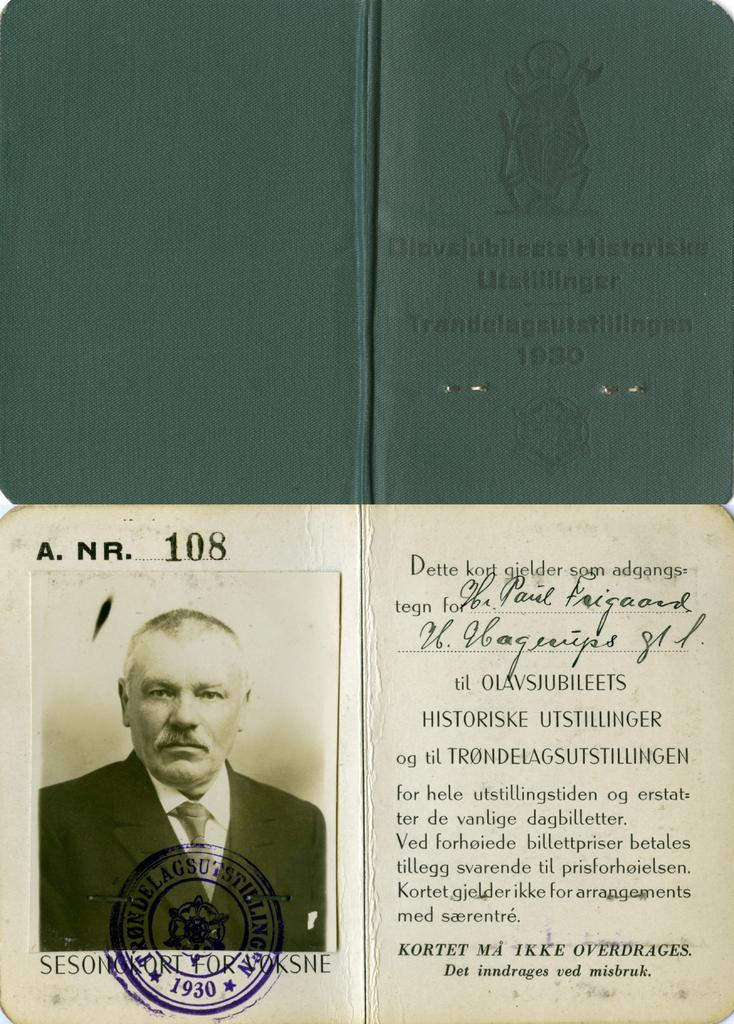<image>
Give a short and clear explanation of the subsequent image. A document with a picture is stamped with the year 1930. 